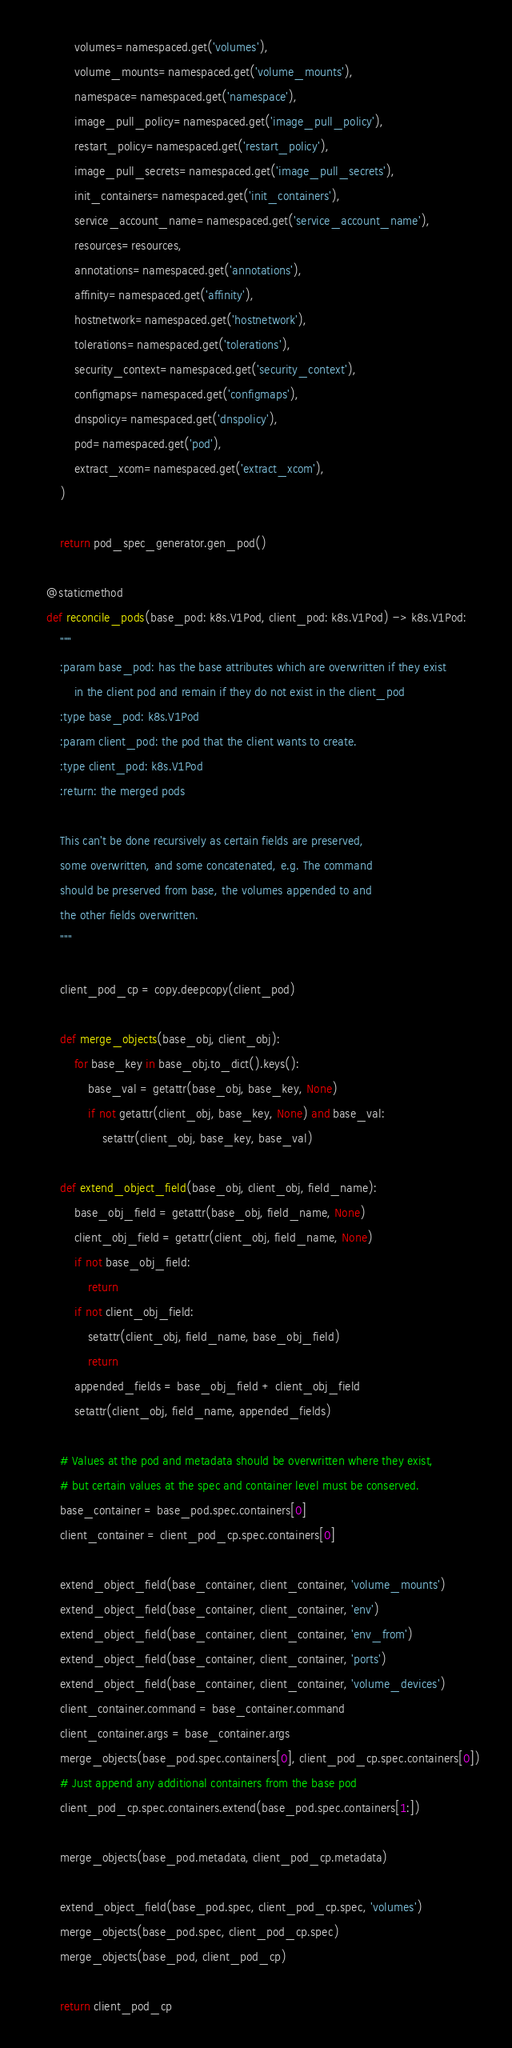<code> <loc_0><loc_0><loc_500><loc_500><_Python_>            volumes=namespaced.get('volumes'),
            volume_mounts=namespaced.get('volume_mounts'),
            namespace=namespaced.get('namespace'),
            image_pull_policy=namespaced.get('image_pull_policy'),
            restart_policy=namespaced.get('restart_policy'),
            image_pull_secrets=namespaced.get('image_pull_secrets'),
            init_containers=namespaced.get('init_containers'),
            service_account_name=namespaced.get('service_account_name'),
            resources=resources,
            annotations=namespaced.get('annotations'),
            affinity=namespaced.get('affinity'),
            hostnetwork=namespaced.get('hostnetwork'),
            tolerations=namespaced.get('tolerations'),
            security_context=namespaced.get('security_context'),
            configmaps=namespaced.get('configmaps'),
            dnspolicy=namespaced.get('dnspolicy'),
            pod=namespaced.get('pod'),
            extract_xcom=namespaced.get('extract_xcom'),
        )

        return pod_spec_generator.gen_pod()

    @staticmethod
    def reconcile_pods(base_pod: k8s.V1Pod, client_pod: k8s.V1Pod) -> k8s.V1Pod:
        """
        :param base_pod: has the base attributes which are overwritten if they exist
            in the client pod and remain if they do not exist in the client_pod
        :type base_pod: k8s.V1Pod
        :param client_pod: the pod that the client wants to create.
        :type client_pod: k8s.V1Pod
        :return: the merged pods

        This can't be done recursively as certain fields are preserved,
        some overwritten, and some concatenated, e.g. The command
        should be preserved from base, the volumes appended to and
        the other fields overwritten.
        """

        client_pod_cp = copy.deepcopy(client_pod)

        def merge_objects(base_obj, client_obj):
            for base_key in base_obj.to_dict().keys():
                base_val = getattr(base_obj, base_key, None)
                if not getattr(client_obj, base_key, None) and base_val:
                    setattr(client_obj, base_key, base_val)

        def extend_object_field(base_obj, client_obj, field_name):
            base_obj_field = getattr(base_obj, field_name, None)
            client_obj_field = getattr(client_obj, field_name, None)
            if not base_obj_field:
                return
            if not client_obj_field:
                setattr(client_obj, field_name, base_obj_field)
                return
            appended_fields = base_obj_field + client_obj_field
            setattr(client_obj, field_name, appended_fields)

        # Values at the pod and metadata should be overwritten where they exist,
        # but certain values at the spec and container level must be conserved.
        base_container = base_pod.spec.containers[0]
        client_container = client_pod_cp.spec.containers[0]

        extend_object_field(base_container, client_container, 'volume_mounts')
        extend_object_field(base_container, client_container, 'env')
        extend_object_field(base_container, client_container, 'env_from')
        extend_object_field(base_container, client_container, 'ports')
        extend_object_field(base_container, client_container, 'volume_devices')
        client_container.command = base_container.command
        client_container.args = base_container.args
        merge_objects(base_pod.spec.containers[0], client_pod_cp.spec.containers[0])
        # Just append any additional containers from the base pod
        client_pod_cp.spec.containers.extend(base_pod.spec.containers[1:])

        merge_objects(base_pod.metadata, client_pod_cp.metadata)

        extend_object_field(base_pod.spec, client_pod_cp.spec, 'volumes')
        merge_objects(base_pod.spec, client_pod_cp.spec)
        merge_objects(base_pod, client_pod_cp)

        return client_pod_cp
</code> 